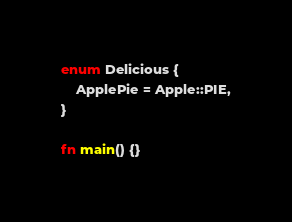<code> <loc_0><loc_0><loc_500><loc_500><_Rust_>enum Delicious {
    ApplePie = Apple::PIE,
}

fn main() {}
</code> 